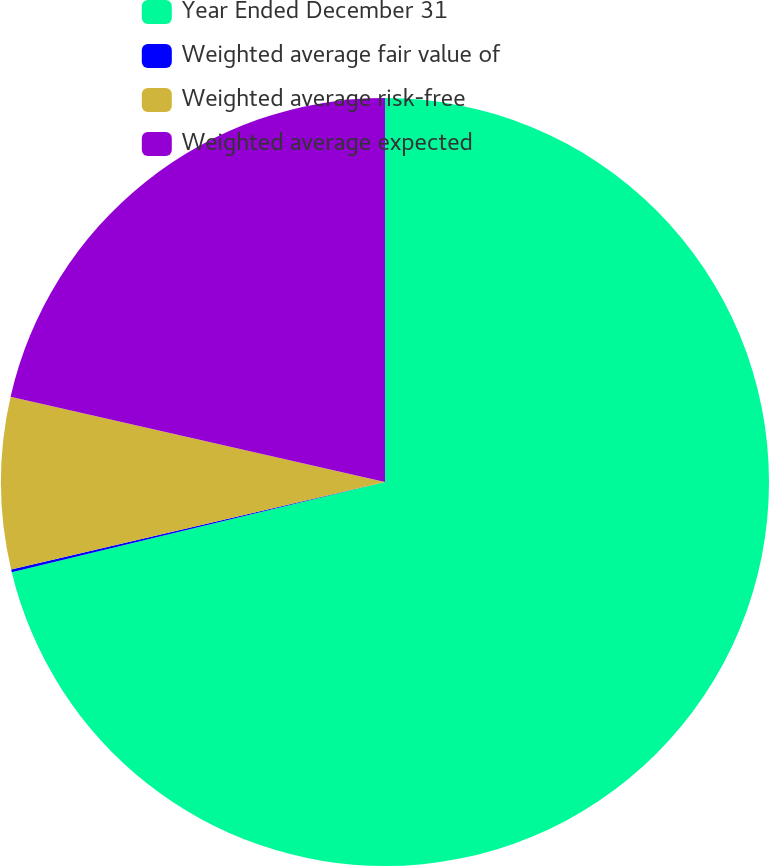Convert chart. <chart><loc_0><loc_0><loc_500><loc_500><pie_chart><fcel>Year Ended December 31<fcel>Weighted average fair value of<fcel>Weighted average risk-free<fcel>Weighted average expected<nl><fcel>71.22%<fcel>0.11%<fcel>7.22%<fcel>21.44%<nl></chart> 